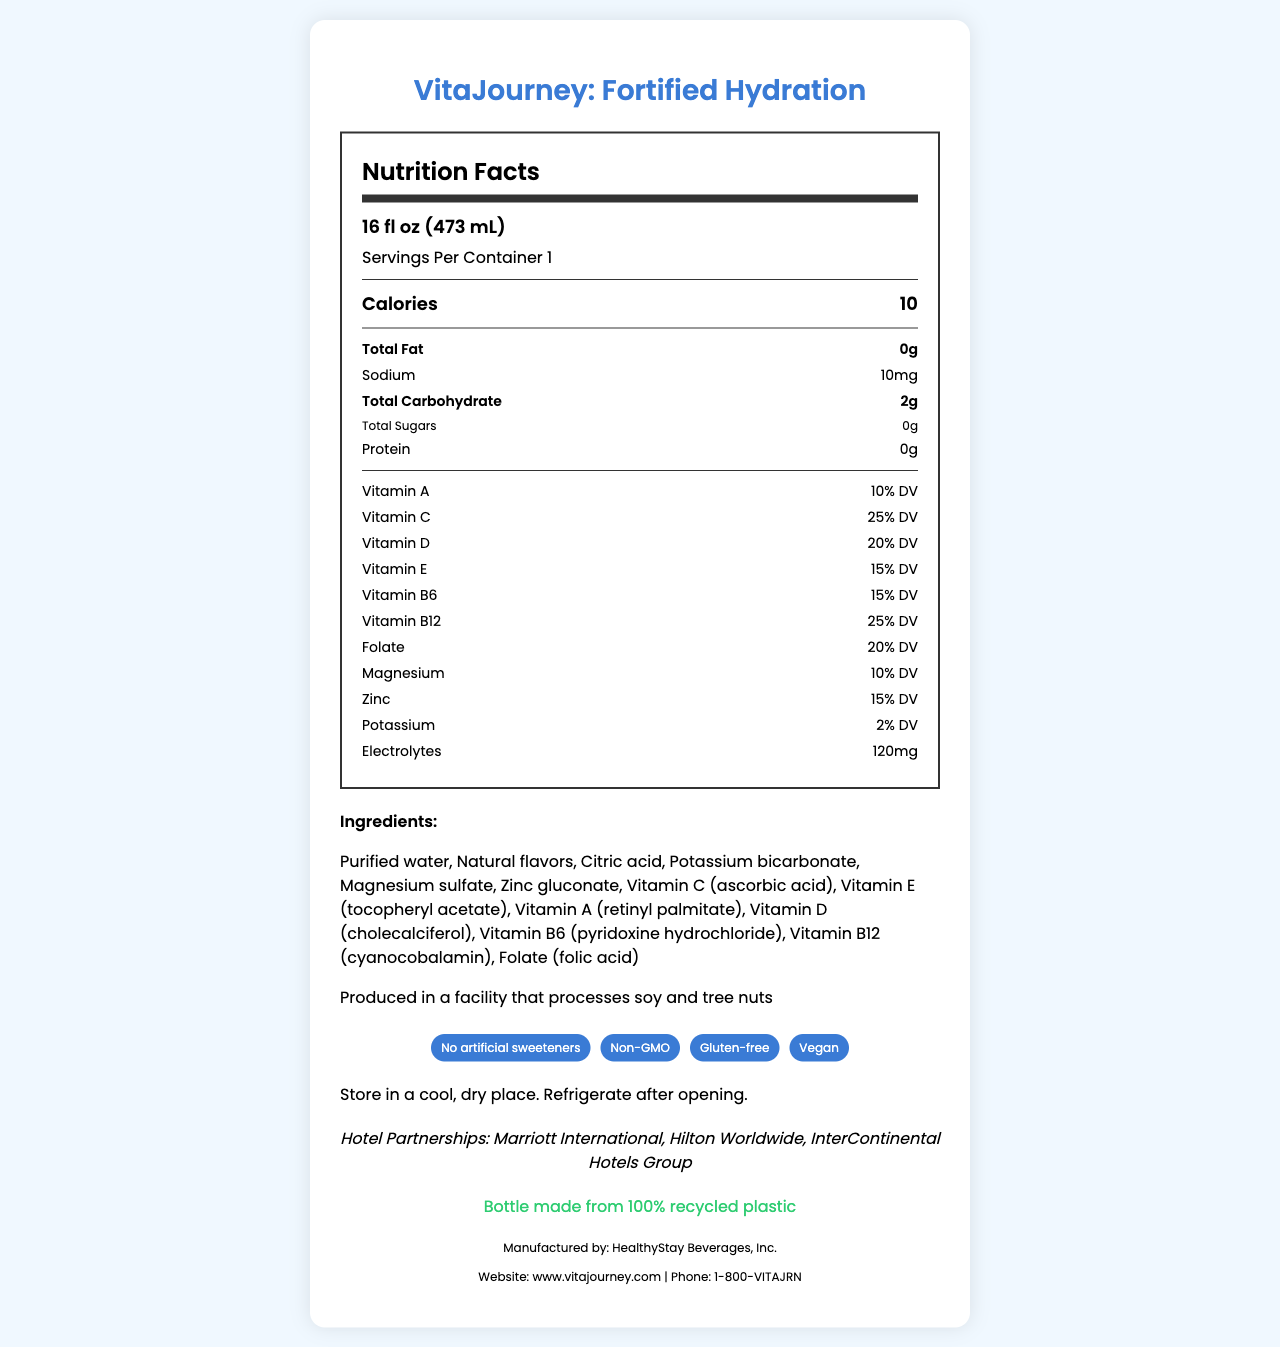what is the serving size of the product? The serving size is listed at the top of the Nutrition Facts section in the document.
Answer: 16 fl oz (473 mL) how many calories are in one serving? The calories per serving are listed under "Calories" in the Nutrition Facts section.
Answer: 10 how much sodium does the product contain? The sodium content is listed under "Sodium" in the Nutrition Facts section.
Answer: 10 mg how much Vitamin C does the product provide? The Vitamin C content is listed under "Vitamin C" in the percentage of daily value (% DV) format.
Answer: 25% DV list two vitamins found in the product. Vitamins included in the product are listed under "Nutrition Facts", such as Vitamin A and Vitamin B12.
Answer: Vitamin A, Vitamin B12 which vitamin has the highest % daily value in this product? A. Vitamin C B. Vitamin D C. Folate D. Magnesium The highest % daily value (25% DV) is for Vitamin C, according to the Nutrition Facts.
Answer: A. Vitamin C which of the following is NOT an ingredient in the product? A. Citric acid B. High fructose corn syrup C. Magnesium sulfate D. Zinc gluconate High fructose corn syrup is not listed among the ingredients of the product.
Answer: B. High fructose corn syrup does the product contain artificial sweeteners? The document states "No artificial sweeteners" under product claims.
Answer: No is this product gluten-free? The product is listed as "Gluten-free" in the product claims section.
Answer: Yes does the product contain any allergens? The allergen information mentions that it is "Produced in a facility that processes soy and tree nuts."
Answer: Yes how should the product be stored after opening? The storage instructions specify to refrigerate the product after opening.
Answer: Refrigerate after opening what are the sustainability features of the product packaging? The sustainability section mentions that the bottle is made from 100% recycled plastic.
Answer: Bottle made from 100% recycled plastic what is the intended target audience for this product? The target audience includes business travelers, fitness enthusiasts, and wellness-focused tourists, as listed in the document.
Answer: Business travelers, Fitness enthusiasts, Wellness-focused tourists which hotel partnerships are mentioned for this product? A. Marriott International, Hilton Worldwide, InterContinental Hotels Group B. Hyatt Hotels, Wyndham Hotels, Radisson Hotels C. Best Western, Choice Hotels, Extended Stay America The hotel partnerships listed in the document are Marriott International, Hilton Worldwide, and InterContinental Hotels Group.
Answer: A. Marriott International, Hilton Worldwide, InterContinental Hotels Group summarize the main idea of the document. The document serves as a comprehensive overview of a vitamin-fortified bottled water product, highlighting its benefits, nutritional values, target audience, and additional features like sustainability efforts and hotel partnerships.
Answer: This document provides detailed nutrition facts and product information about "VitaJourney: Fortified Hydration," a vitamin-fortified bottled water tailored for health-conscious travelers and hotel guests. It includes nutritional content, ingredients, storage instructions, hotel partnerships, target audience, sustainability initiatives, and contact information. what is the exact electrolyte content in the product? The electrolyte content specified in the Nutrition Facts section is 120 mg.
Answer: 120 mg which vitamins in the product are water-soluble? The document lists several vitamins but does not specify which ones are water-soluble and which are fat-soluble.
Answer: Cannot be determined what are the claims made about the product? The product claims section provides these specific claims about the product's attributes.
Answer: No artificial sweeteners, Non-GMO, Gluten-free, Vegan 